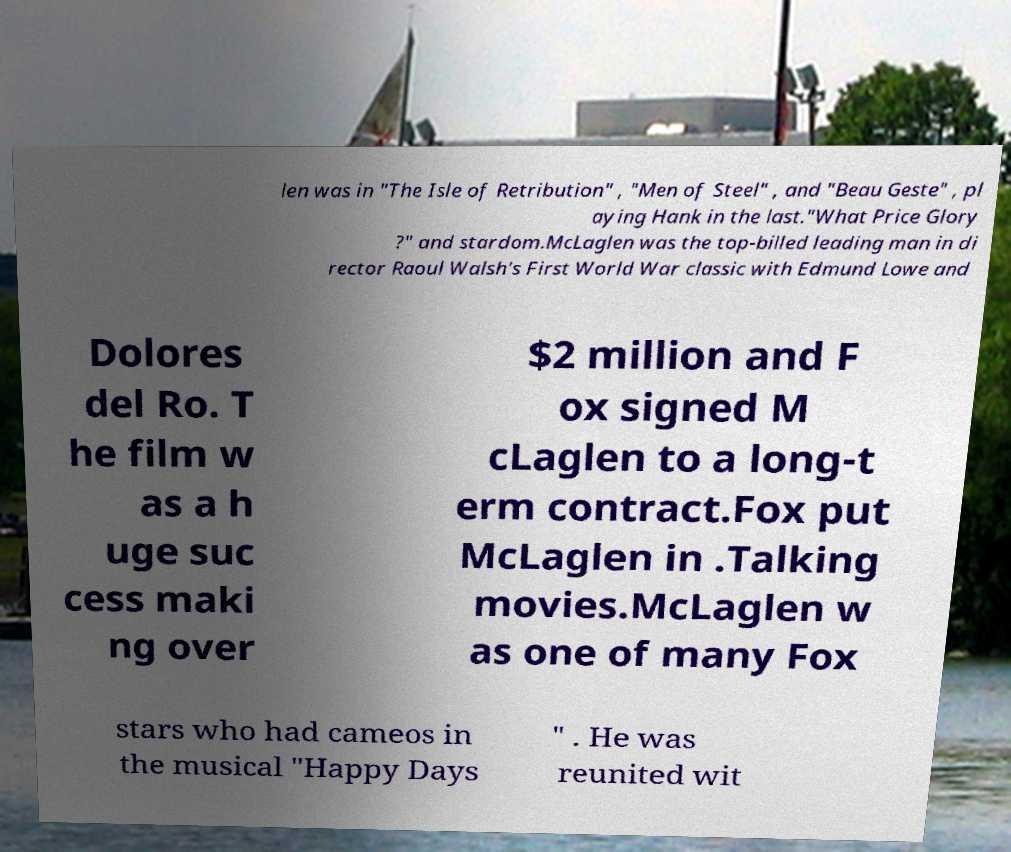Could you extract and type out the text from this image? len was in "The Isle of Retribution" , "Men of Steel" , and "Beau Geste" , pl aying Hank in the last."What Price Glory ?" and stardom.McLaglen was the top-billed leading man in di rector Raoul Walsh's First World War classic with Edmund Lowe and Dolores del Ro. T he film w as a h uge suc cess maki ng over $2 million and F ox signed M cLaglen to a long-t erm contract.Fox put McLaglen in .Talking movies.McLaglen w as one of many Fox stars who had cameos in the musical "Happy Days " . He was reunited wit 